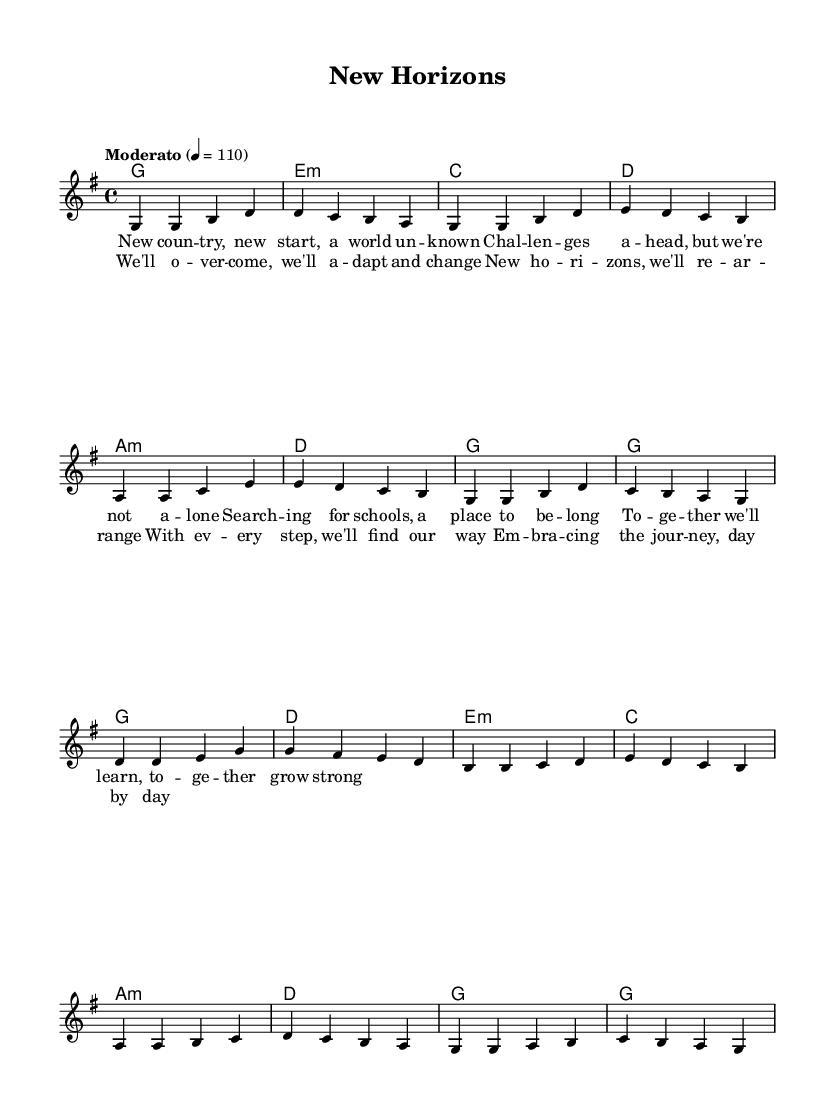What is the key signature of this music? The key signature is G major, which has one sharp (F#).
Answer: G major What is the time signature of this music? The time signature shown is 4/4, indicating four beats per measure.
Answer: 4/4 What is the tempo marking of this piece? The tempo marking is "Moderato," suggesting a moderate speed, and the metronome marking is set at 110 beats per minute.
Answer: Moderato How many measures are there in the verse? The verse consists of eight measures, as counted from the musical notation.
Answer: Eight measures In the chorus, what is the first note played? The first note of the chorus is D, as indicated in the melody line.
Answer: D What is the overall theme expressed in the lyrics? The lyrics convey a message of overcoming challenges and finding new beginnings, emphasizing adaptation and growth.
Answer: Overcoming challenges How does the harmonic structure in the verse relate to the melody? The chords in the harmonic structure support and complement the melody, providing a foundation for the vocal line and enhancing the emotional impact. Overall, the harmonic progression matches the lyrical phrases in the melody, creating unity.
Answer: Complementary 